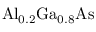Convert formula to latex. <formula><loc_0><loc_0><loc_500><loc_500>{ A l } _ { 0 . 2 } \mathrm { { G a } _ { 0 . 8 } \mathrm { A s } }</formula> 